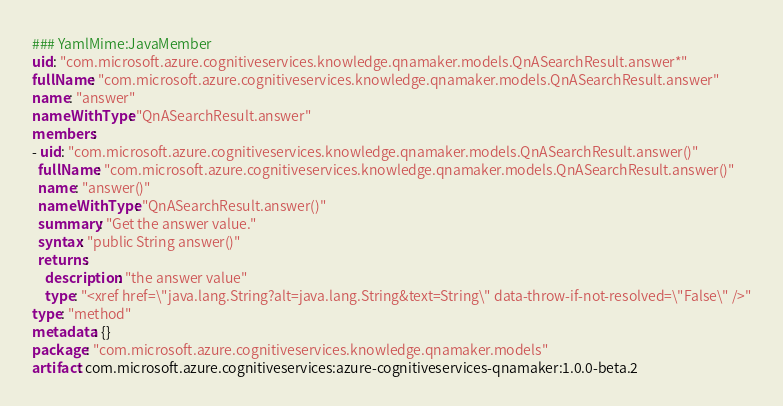<code> <loc_0><loc_0><loc_500><loc_500><_YAML_>### YamlMime:JavaMember
uid: "com.microsoft.azure.cognitiveservices.knowledge.qnamaker.models.QnASearchResult.answer*"
fullName: "com.microsoft.azure.cognitiveservices.knowledge.qnamaker.models.QnASearchResult.answer"
name: "answer"
nameWithType: "QnASearchResult.answer"
members:
- uid: "com.microsoft.azure.cognitiveservices.knowledge.qnamaker.models.QnASearchResult.answer()"
  fullName: "com.microsoft.azure.cognitiveservices.knowledge.qnamaker.models.QnASearchResult.answer()"
  name: "answer()"
  nameWithType: "QnASearchResult.answer()"
  summary: "Get the answer value."
  syntax: "public String answer()"
  returns:
    description: "the answer value"
    type: "<xref href=\"java.lang.String?alt=java.lang.String&text=String\" data-throw-if-not-resolved=\"False\" />"
type: "method"
metadata: {}
package: "com.microsoft.azure.cognitiveservices.knowledge.qnamaker.models"
artifact: com.microsoft.azure.cognitiveservices:azure-cognitiveservices-qnamaker:1.0.0-beta.2
</code> 